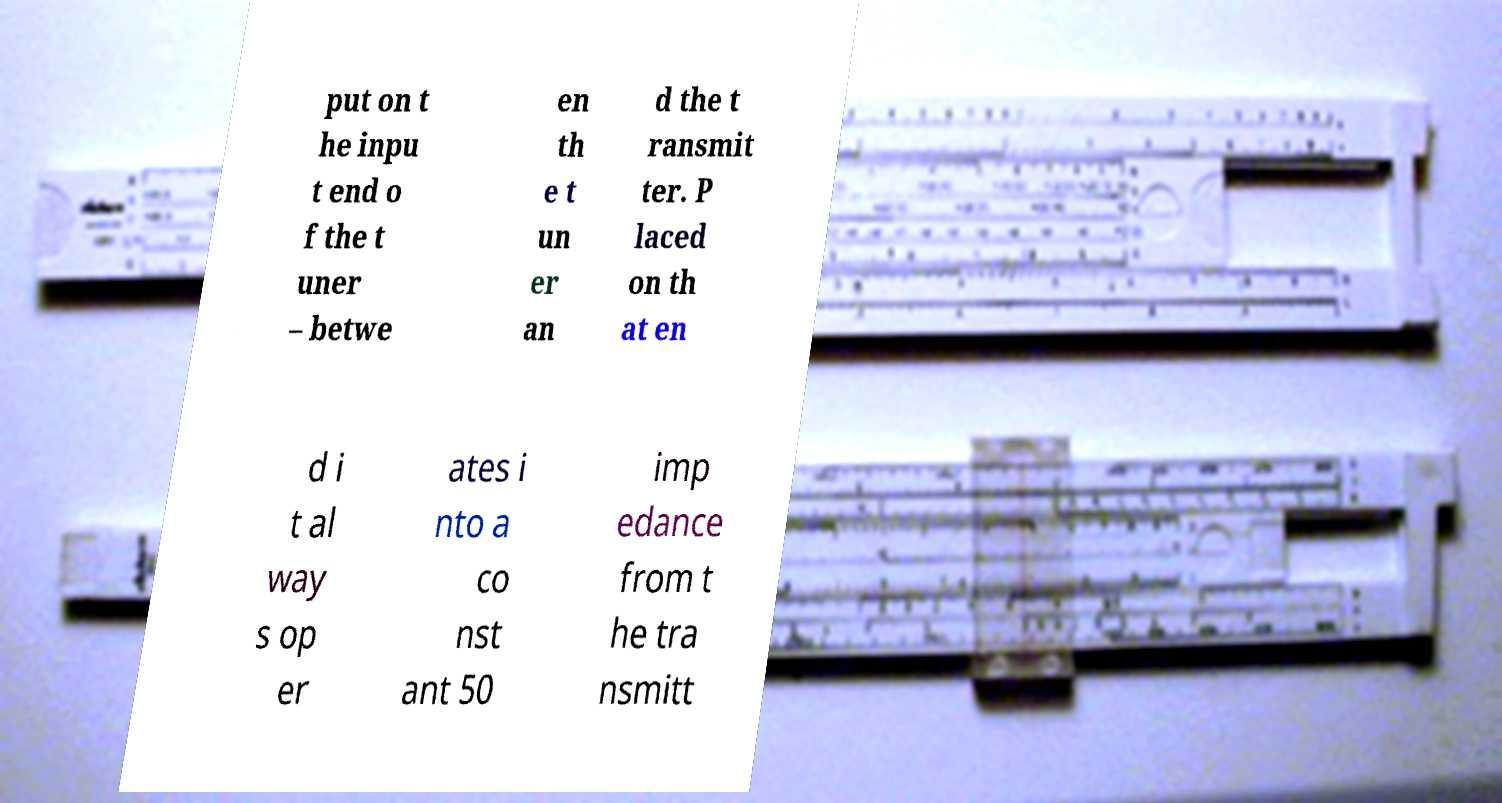Can you accurately transcribe the text from the provided image for me? put on t he inpu t end o f the t uner – betwe en th e t un er an d the t ransmit ter. P laced on th at en d i t al way s op er ates i nto a co nst ant 50 imp edance from t he tra nsmitt 